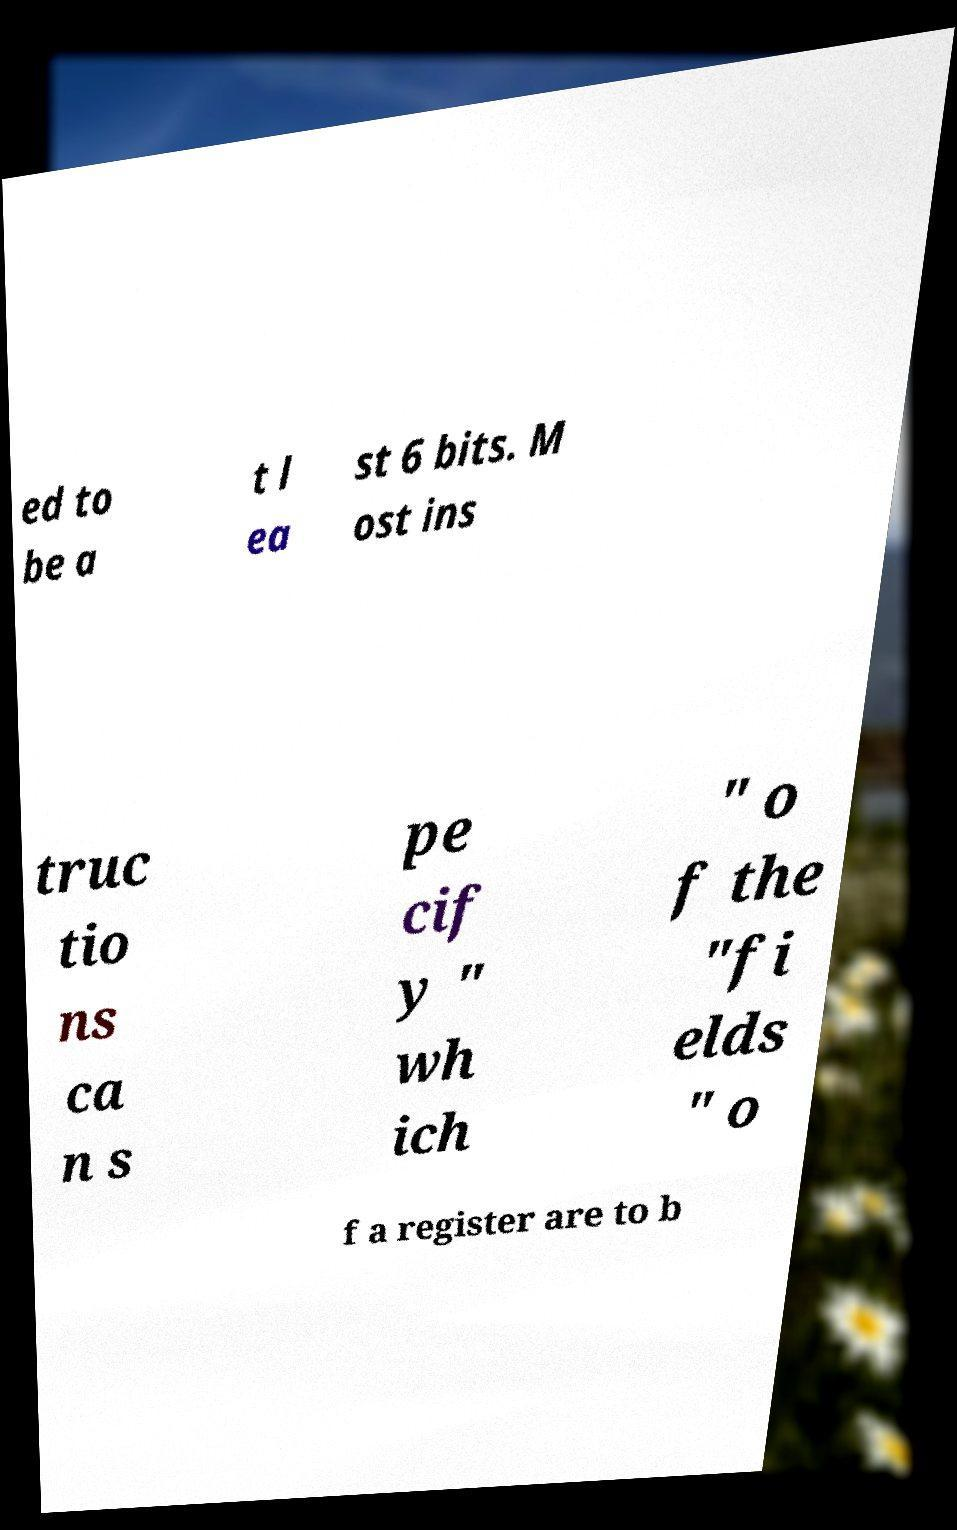Could you assist in decoding the text presented in this image and type it out clearly? ed to be a t l ea st 6 bits. M ost ins truc tio ns ca n s pe cif y " wh ich " o f the "fi elds " o f a register are to b 